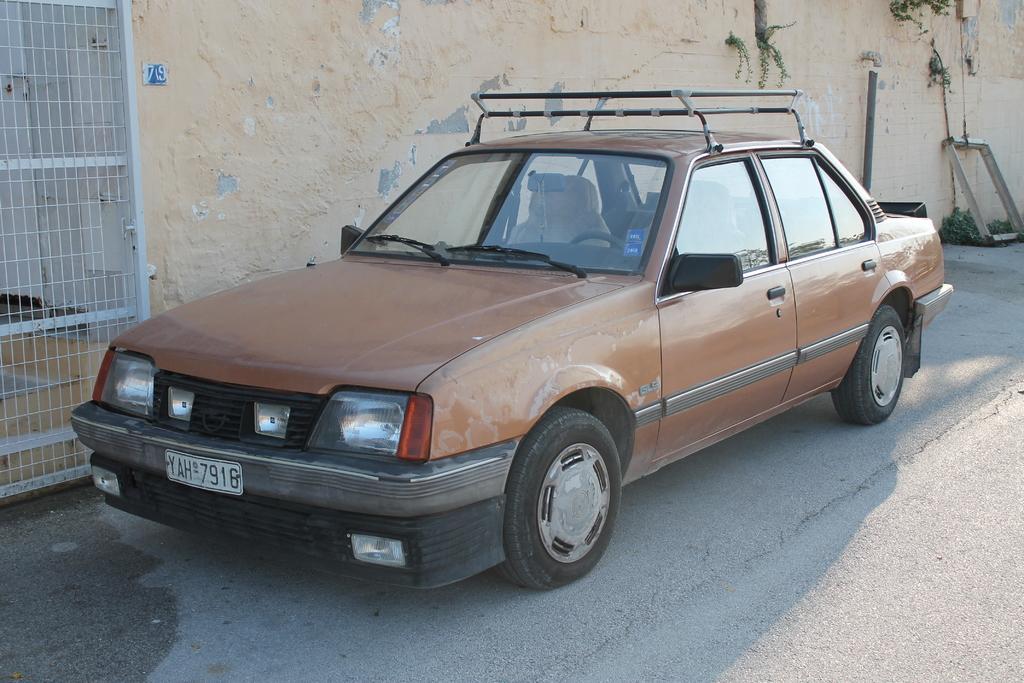Could you give a brief overview of what you see in this image? In the picture I can see there is a car parked here on the road and it has head lights, a number plate, door and a number plate. There is a wall in the backdrop and a gate. 